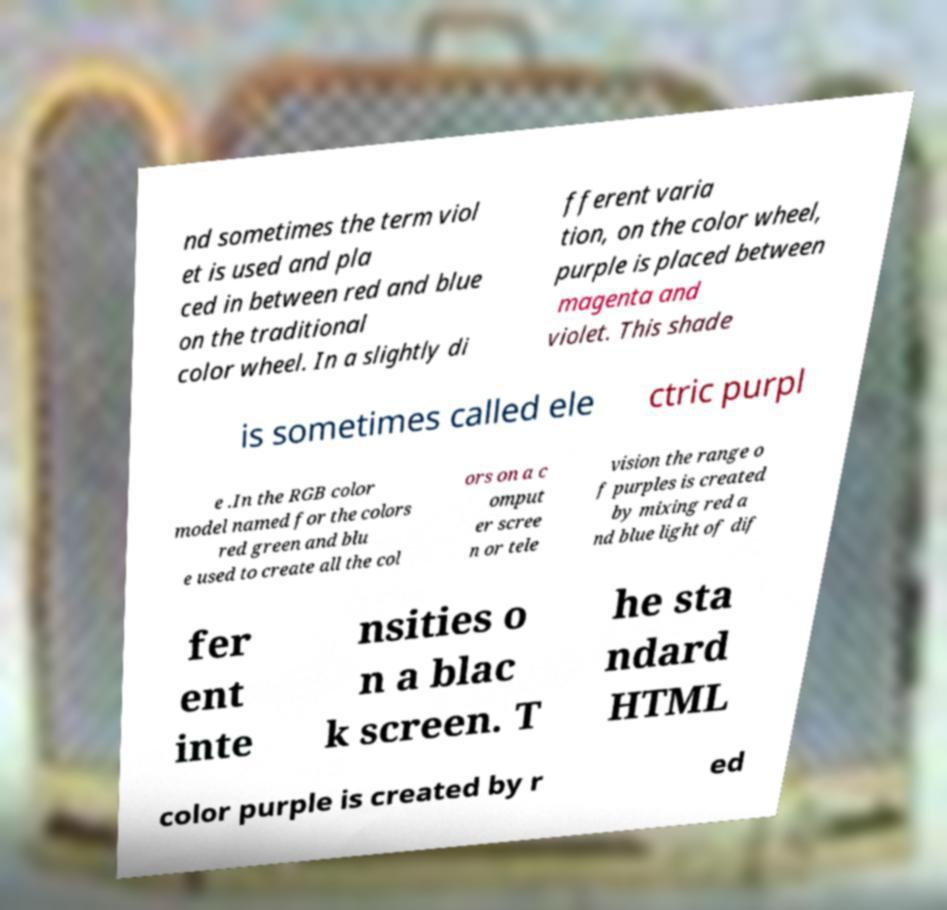Please read and relay the text visible in this image. What does it say? nd sometimes the term viol et is used and pla ced in between red and blue on the traditional color wheel. In a slightly di fferent varia tion, on the color wheel, purple is placed between magenta and violet. This shade is sometimes called ele ctric purpl e .In the RGB color model named for the colors red green and blu e used to create all the col ors on a c omput er scree n or tele vision the range o f purples is created by mixing red a nd blue light of dif fer ent inte nsities o n a blac k screen. T he sta ndard HTML color purple is created by r ed 